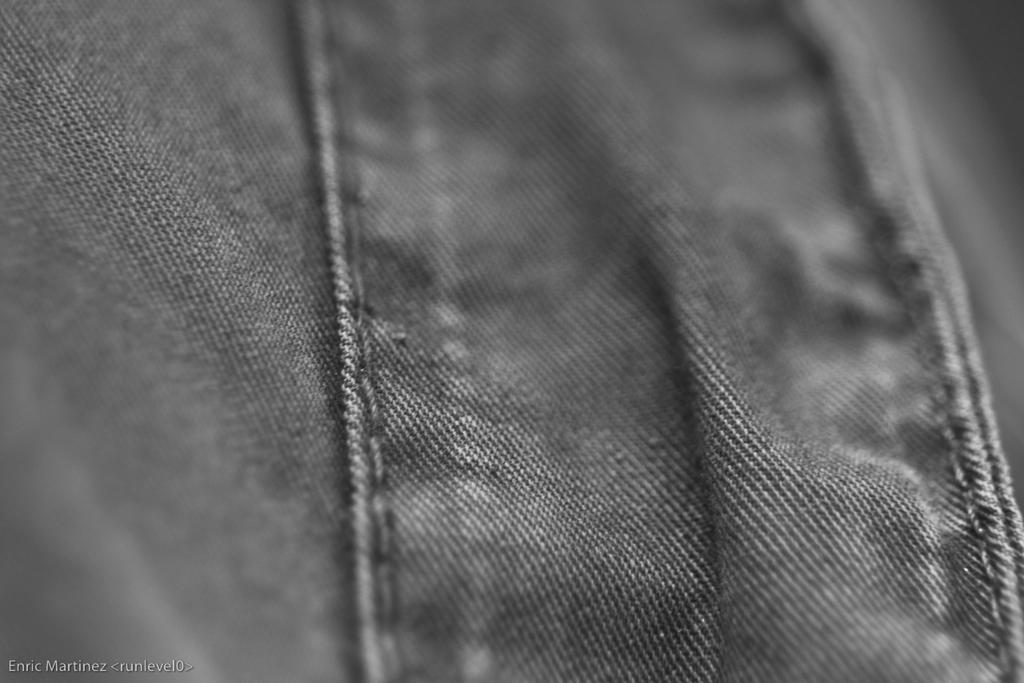Please provide a concise description of this image. In this image there is a jeans. At the bottom left side of the image there is some text. 